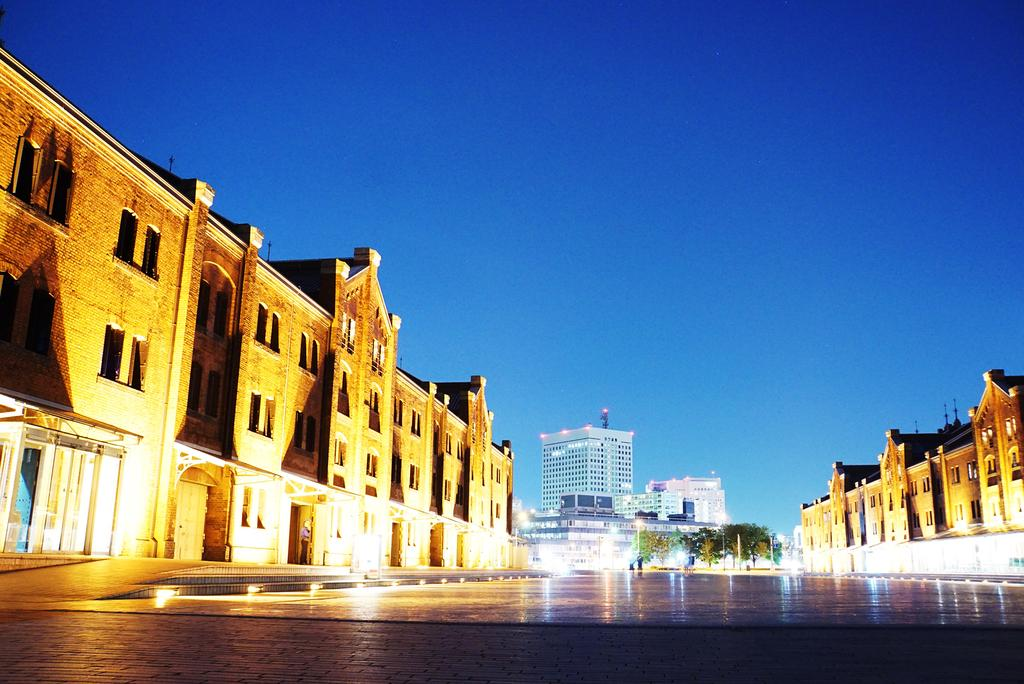What type of structures can be seen in the image? There are buildings in the image. What else is visible in the image besides the buildings? There are lights and trees in the background of the image. What can be seen in the sky in the image? The sky is visible in the background of the image. What route does the governor take to reach the head office in the image? There is no governor or head office present in the image, so it is not possible to determine a route. 